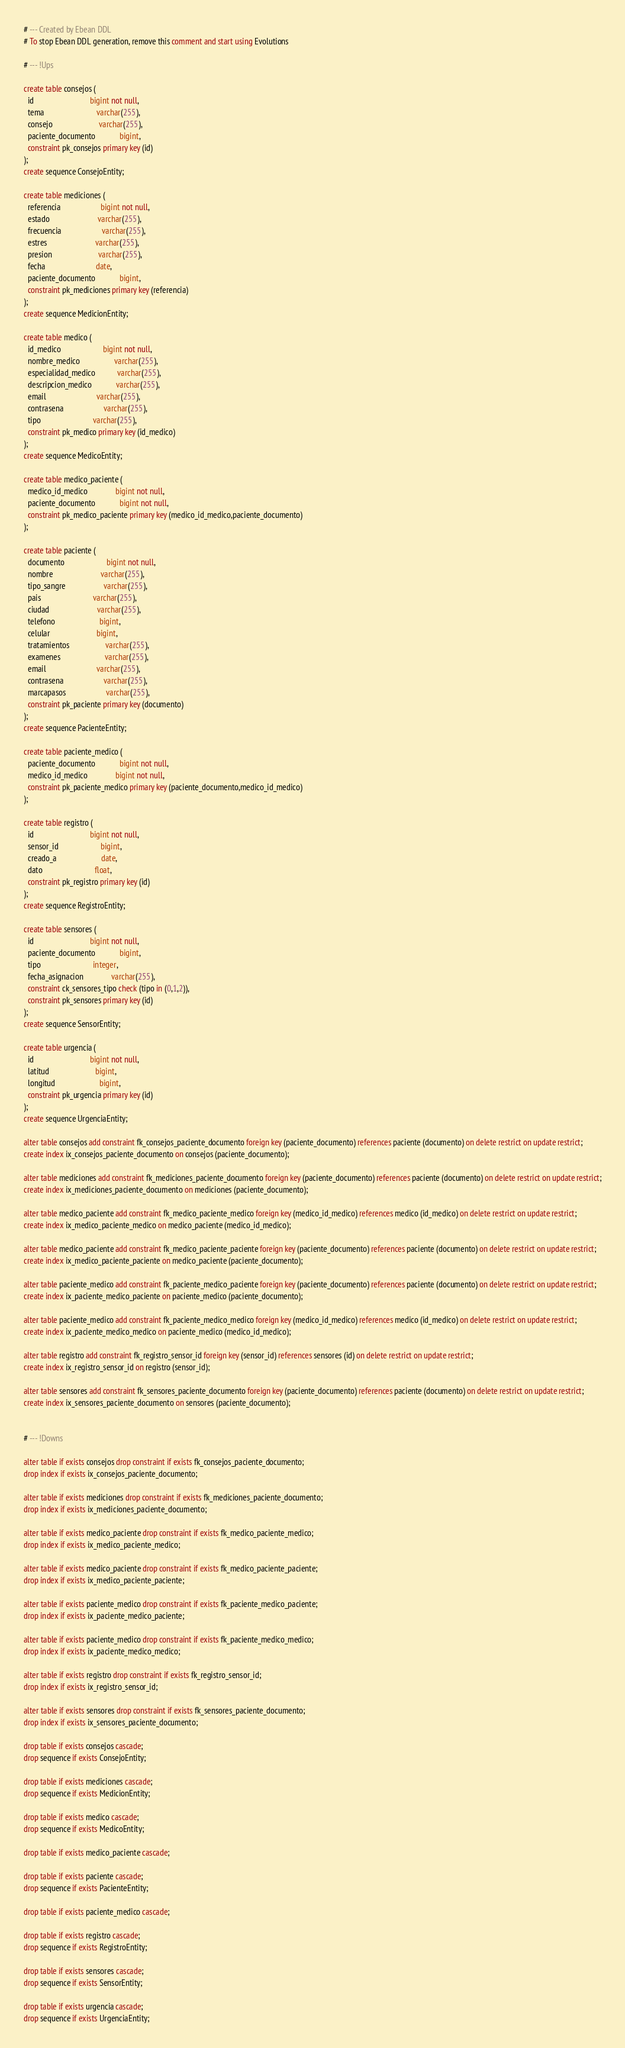Convert code to text. <code><loc_0><loc_0><loc_500><loc_500><_SQL_># --- Created by Ebean DDL
# To stop Ebean DDL generation, remove this comment and start using Evolutions

# --- !Ups

create table consejos (
  id                            bigint not null,
  tema                          varchar(255),
  consejo                       varchar(255),
  paciente_documento            bigint,
  constraint pk_consejos primary key (id)
);
create sequence ConsejoEntity;

create table mediciones (
  referencia                    bigint not null,
  estado                        varchar(255),
  frecuencia                    varchar(255),
  estres                        varchar(255),
  presion                       varchar(255),
  fecha                         date,
  paciente_documento            bigint,
  constraint pk_mediciones primary key (referencia)
);
create sequence MedicionEntity;

create table medico (
  id_medico                     bigint not null,
  nombre_medico                 varchar(255),
  especialidad_medico           varchar(255),
  descripcion_medico            varchar(255),
  email                         varchar(255),
  contrasena                    varchar(255),
  tipo                          varchar(255),
  constraint pk_medico primary key (id_medico)
);
create sequence MedicoEntity;

create table medico_paciente (
  medico_id_medico              bigint not null,
  paciente_documento            bigint not null,
  constraint pk_medico_paciente primary key (medico_id_medico,paciente_documento)
);

create table paciente (
  documento                     bigint not null,
  nombre                        varchar(255),
  tipo_sangre                   varchar(255),
  pais                          varchar(255),
  ciudad                        varchar(255),
  telefono                      bigint,
  celular                       bigint,
  tratamientos                  varchar(255),
  examenes                      varchar(255),
  email                         varchar(255),
  contrasena                    varchar(255),
  marcapasos                    varchar(255),
  constraint pk_paciente primary key (documento)
);
create sequence PacienteEntity;

create table paciente_medico (
  paciente_documento            bigint not null,
  medico_id_medico              bigint not null,
  constraint pk_paciente_medico primary key (paciente_documento,medico_id_medico)
);

create table registro (
  id                            bigint not null,
  sensor_id                     bigint,
  creado_a                      date,
  dato                          float,
  constraint pk_registro primary key (id)
);
create sequence RegistroEntity;

create table sensores (
  id                            bigint not null,
  paciente_documento            bigint,
  tipo                          integer,
  fecha_asignacion              varchar(255),
  constraint ck_sensores_tipo check (tipo in (0,1,2)),
  constraint pk_sensores primary key (id)
);
create sequence SensorEntity;

create table urgencia (
  id                            bigint not null,
  latitud                       bigint,
  longitud                      bigint,
  constraint pk_urgencia primary key (id)
);
create sequence UrgenciaEntity;

alter table consejos add constraint fk_consejos_paciente_documento foreign key (paciente_documento) references paciente (documento) on delete restrict on update restrict;
create index ix_consejos_paciente_documento on consejos (paciente_documento);

alter table mediciones add constraint fk_mediciones_paciente_documento foreign key (paciente_documento) references paciente (documento) on delete restrict on update restrict;
create index ix_mediciones_paciente_documento on mediciones (paciente_documento);

alter table medico_paciente add constraint fk_medico_paciente_medico foreign key (medico_id_medico) references medico (id_medico) on delete restrict on update restrict;
create index ix_medico_paciente_medico on medico_paciente (medico_id_medico);

alter table medico_paciente add constraint fk_medico_paciente_paciente foreign key (paciente_documento) references paciente (documento) on delete restrict on update restrict;
create index ix_medico_paciente_paciente on medico_paciente (paciente_documento);

alter table paciente_medico add constraint fk_paciente_medico_paciente foreign key (paciente_documento) references paciente (documento) on delete restrict on update restrict;
create index ix_paciente_medico_paciente on paciente_medico (paciente_documento);

alter table paciente_medico add constraint fk_paciente_medico_medico foreign key (medico_id_medico) references medico (id_medico) on delete restrict on update restrict;
create index ix_paciente_medico_medico on paciente_medico (medico_id_medico);

alter table registro add constraint fk_registro_sensor_id foreign key (sensor_id) references sensores (id) on delete restrict on update restrict;
create index ix_registro_sensor_id on registro (sensor_id);

alter table sensores add constraint fk_sensores_paciente_documento foreign key (paciente_documento) references paciente (documento) on delete restrict on update restrict;
create index ix_sensores_paciente_documento on sensores (paciente_documento);


# --- !Downs

alter table if exists consejos drop constraint if exists fk_consejos_paciente_documento;
drop index if exists ix_consejos_paciente_documento;

alter table if exists mediciones drop constraint if exists fk_mediciones_paciente_documento;
drop index if exists ix_mediciones_paciente_documento;

alter table if exists medico_paciente drop constraint if exists fk_medico_paciente_medico;
drop index if exists ix_medico_paciente_medico;

alter table if exists medico_paciente drop constraint if exists fk_medico_paciente_paciente;
drop index if exists ix_medico_paciente_paciente;

alter table if exists paciente_medico drop constraint if exists fk_paciente_medico_paciente;
drop index if exists ix_paciente_medico_paciente;

alter table if exists paciente_medico drop constraint if exists fk_paciente_medico_medico;
drop index if exists ix_paciente_medico_medico;

alter table if exists registro drop constraint if exists fk_registro_sensor_id;
drop index if exists ix_registro_sensor_id;

alter table if exists sensores drop constraint if exists fk_sensores_paciente_documento;
drop index if exists ix_sensores_paciente_documento;

drop table if exists consejos cascade;
drop sequence if exists ConsejoEntity;

drop table if exists mediciones cascade;
drop sequence if exists MedicionEntity;

drop table if exists medico cascade;
drop sequence if exists MedicoEntity;

drop table if exists medico_paciente cascade;

drop table if exists paciente cascade;
drop sequence if exists PacienteEntity;

drop table if exists paciente_medico cascade;

drop table if exists registro cascade;
drop sequence if exists RegistroEntity;

drop table if exists sensores cascade;
drop sequence if exists SensorEntity;

drop table if exists urgencia cascade;
drop sequence if exists UrgenciaEntity;</code> 